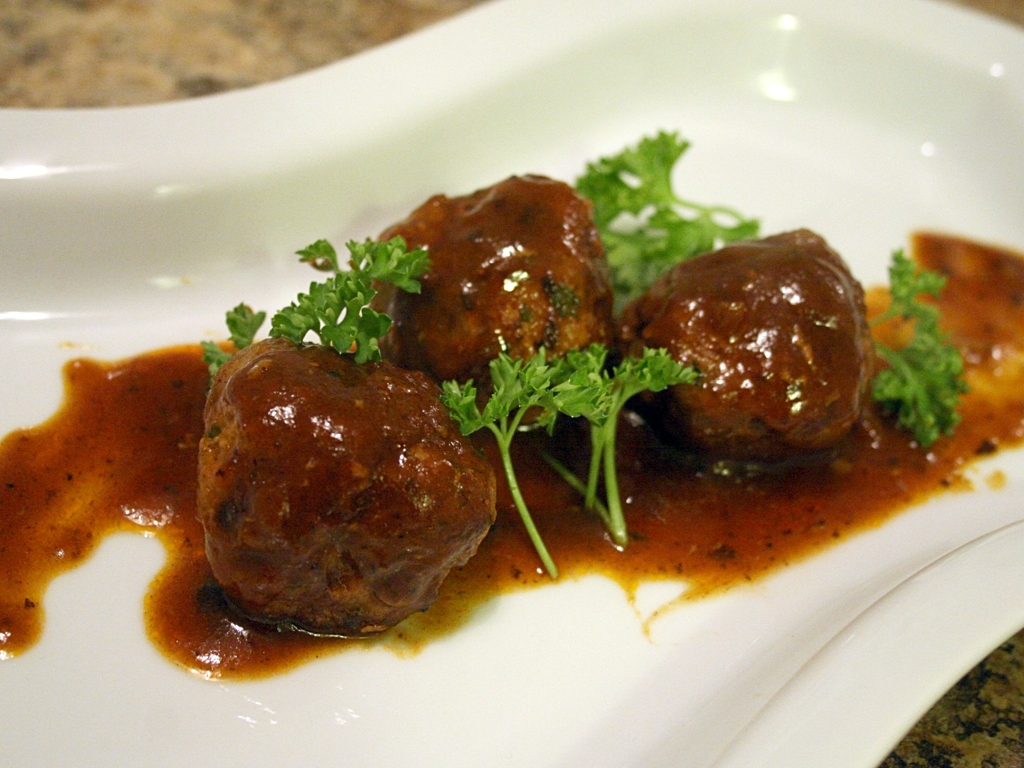Can you describe the texture and possible flavors of the food presented? The meatballs have a glossy and slightly rough texture indicative of a well-browned exterior, likely offering a savory taste with a hint of herbs. The sauce appears smooth and is likely rich with a blend of aromatic spices, potentially lending a tangy or even a mildly sweet undertone to the dish. 